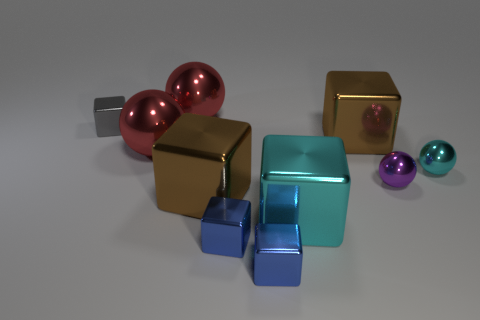Subtract all brown cubes. How many cubes are left? 4 Subtract all big cyan shiny cubes. How many cubes are left? 5 Subtract all cyan spheres. Subtract all purple cubes. How many spheres are left? 3 Subtract all balls. How many objects are left? 6 Add 8 large cyan cubes. How many large cyan cubes are left? 9 Add 1 large red shiny things. How many large red shiny things exist? 3 Subtract 1 gray blocks. How many objects are left? 9 Subtract all small blue blocks. Subtract all small gray shiny cubes. How many objects are left? 7 